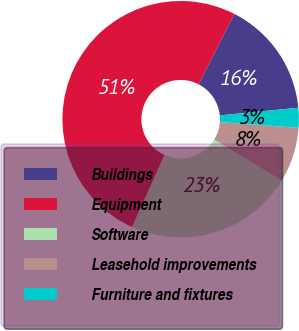<chart> <loc_0><loc_0><loc_500><loc_500><pie_chart><fcel>Buildings<fcel>Equipment<fcel>Software<fcel>Leasehold improvements<fcel>Furniture and fixtures<nl><fcel>15.94%<fcel>50.78%<fcel>23.05%<fcel>7.52%<fcel>2.71%<nl></chart> 